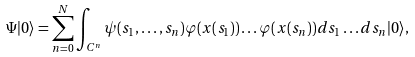Convert formula to latex. <formula><loc_0><loc_0><loc_500><loc_500>\Psi | 0 \rangle = \sum _ { n = 0 } ^ { N } \int _ { C ^ { n } } \psi ( s _ { 1 } , \dots , s _ { n } ) \varphi ( x ( s _ { 1 } ) ) \dots \varphi ( x ( s _ { n } ) ) d s _ { 1 } \dots d s _ { n } | 0 \rangle ,</formula> 